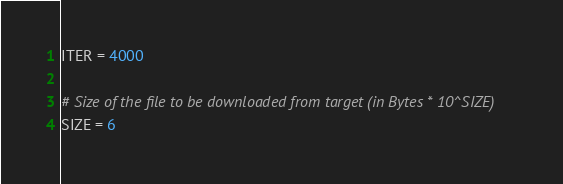<code> <loc_0><loc_0><loc_500><loc_500><_Python_>ITER = 4000

# Size of the file to be downloaded from target (in Bytes * 10^SIZE)
SIZE = 6

</code> 